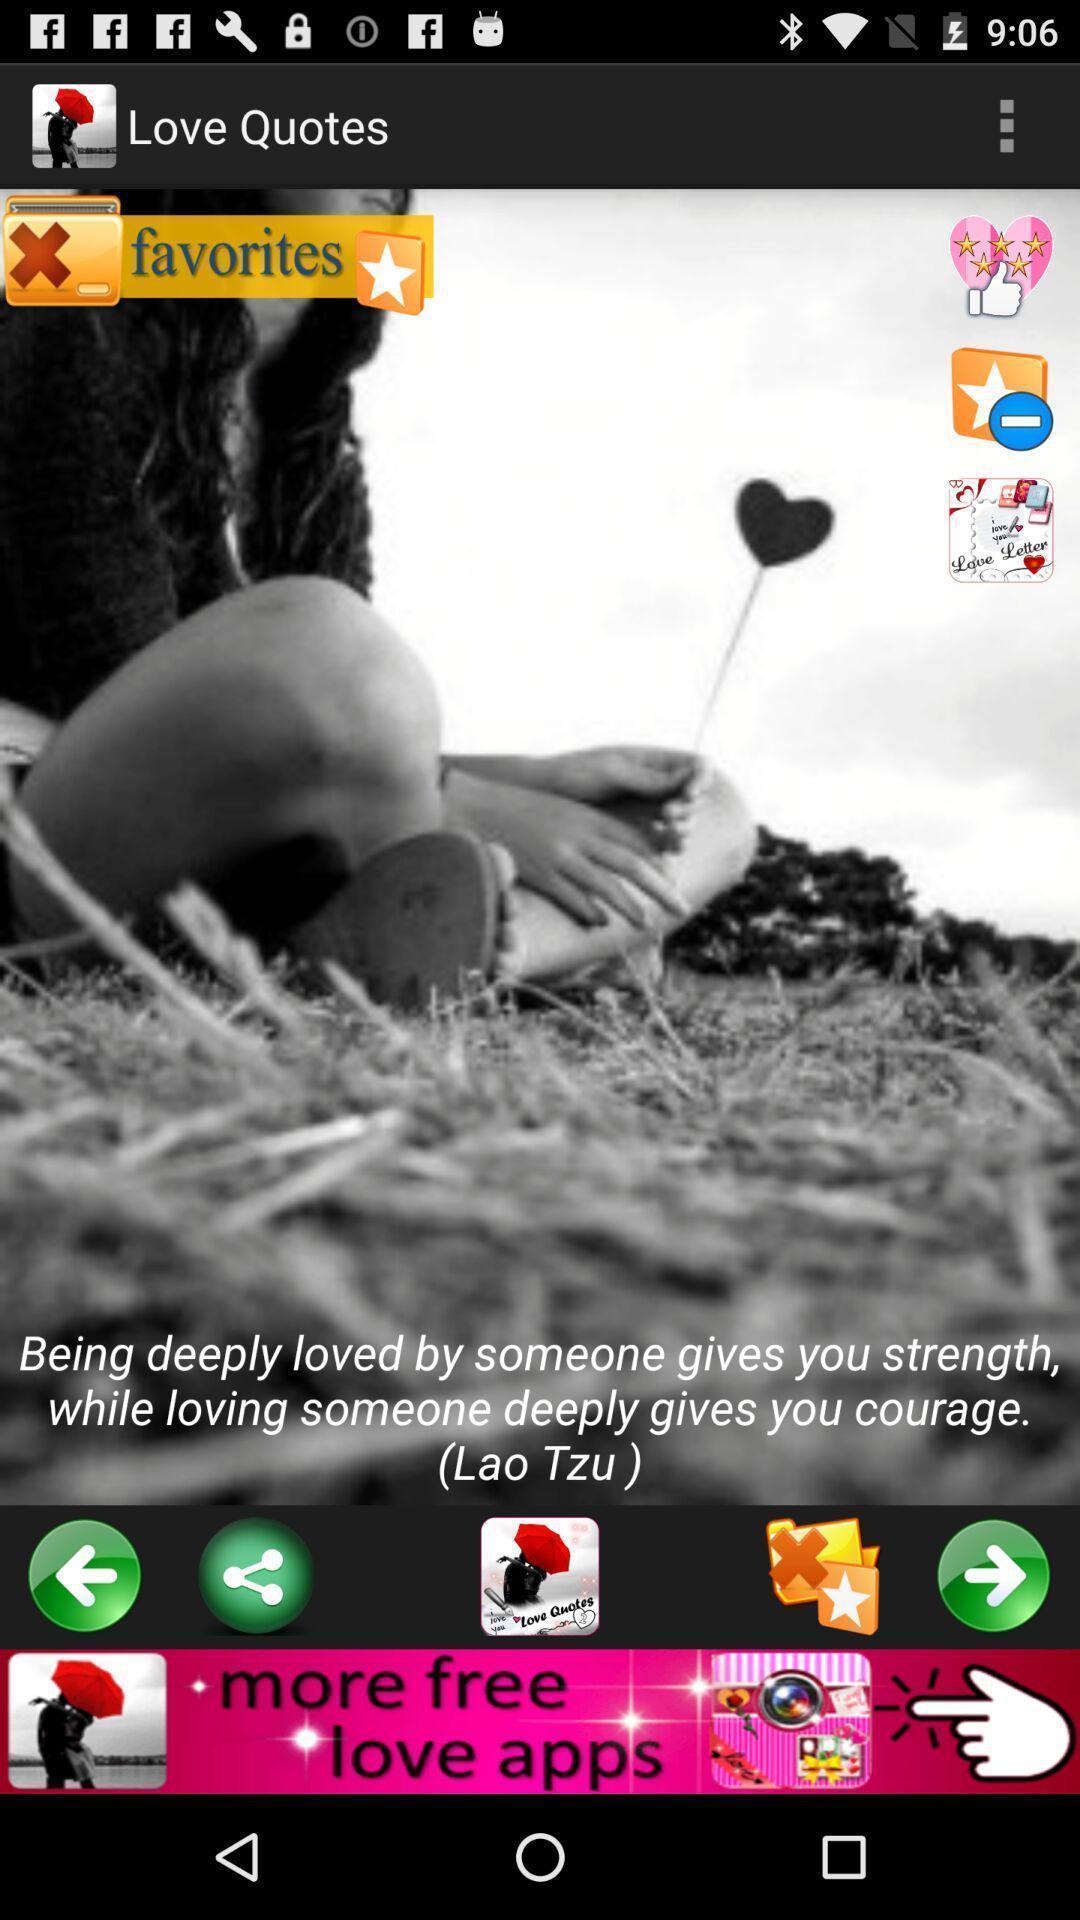Describe this image in words. Screen displaying a quote. 